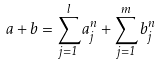<formula> <loc_0><loc_0><loc_500><loc_500>a + b = \sum _ { j = 1 } ^ { l } a _ { j } ^ { n } + \sum _ { j = 1 } ^ { m } b _ { j } ^ { n }</formula> 